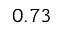<formula> <loc_0><loc_0><loc_500><loc_500>0 . 7 3</formula> 